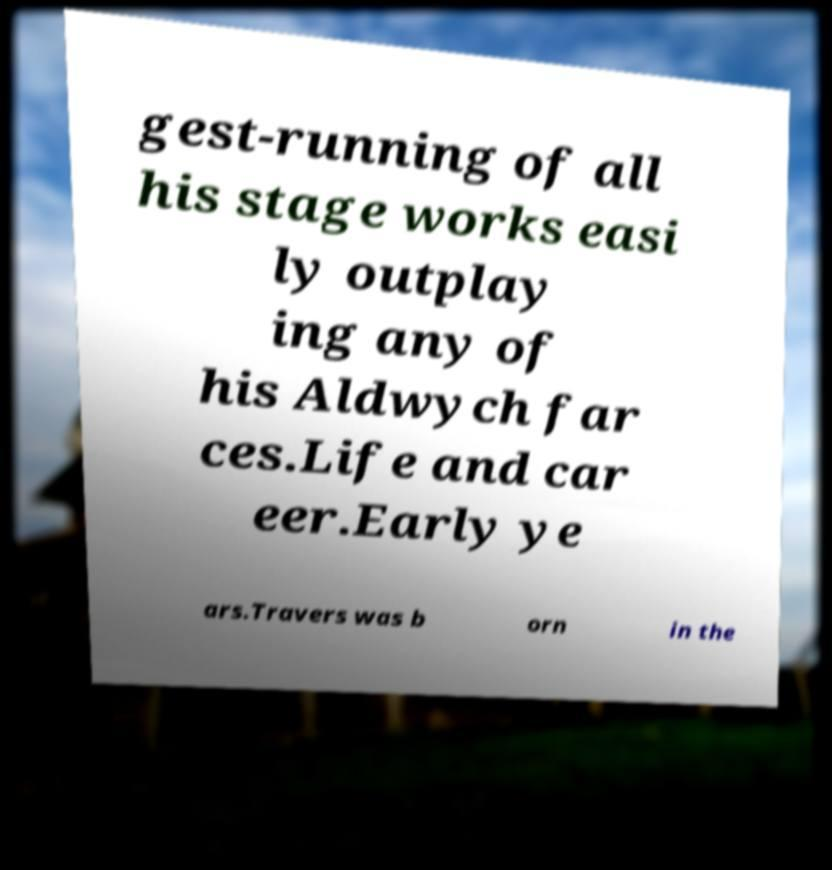Could you assist in decoding the text presented in this image and type it out clearly? gest-running of all his stage works easi ly outplay ing any of his Aldwych far ces.Life and car eer.Early ye ars.Travers was b orn in the 